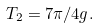Convert formula to latex. <formula><loc_0><loc_0><loc_500><loc_500>T _ { 2 } = 7 \pi / 4 g .</formula> 